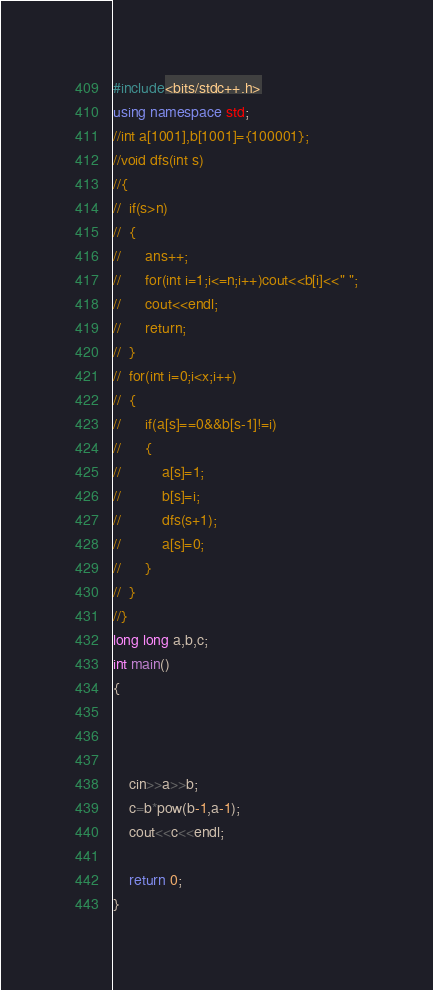Convert code to text. <code><loc_0><loc_0><loc_500><loc_500><_C++_>#include<bits/stdc++.h>
using namespace std;
//int a[1001],b[1001]={100001};
//void dfs(int s)
//{
//	if(s>n)
//	{
//		ans++;
//		for(int i=1;i<=n;i++)cout<<b[i]<<" ";
//		cout<<endl;
//		return;
//	}
//	for(int i=0;i<x;i++)
//	{
//		if(a[s]==0&&b[s-1]!=i)
//		{
//			a[s]=1;
//			b[s]=i;
//			dfs(s+1);
//			a[s]=0;
//		}
//	}
//}
long long a,b,c;
int main()
{



    cin>>a>>b;
    c=b*pow(b-1,a-1);
    cout<<c<<endl;

	return 0;
}
</code> 